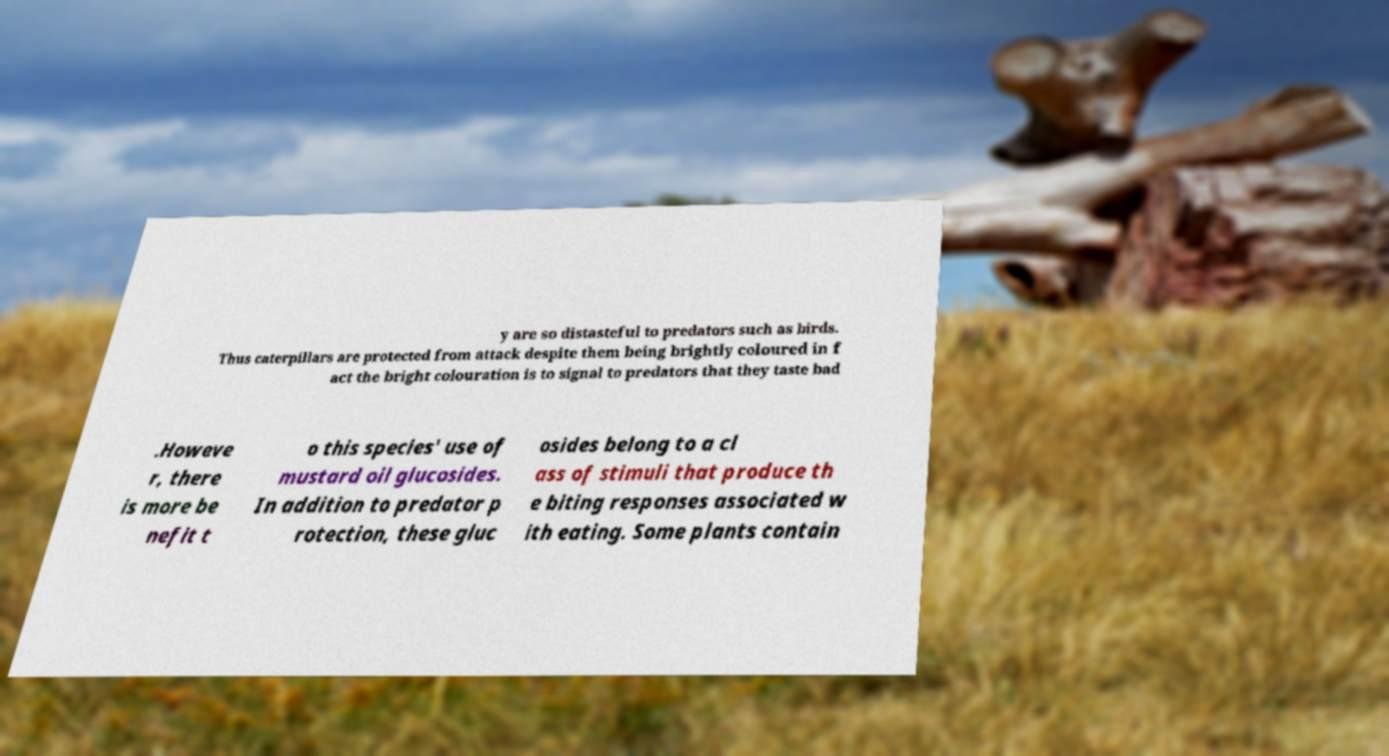What messages or text are displayed in this image? I need them in a readable, typed format. y are so distasteful to predators such as birds. Thus caterpillars are protected from attack despite them being brightly coloured in f act the bright colouration is to signal to predators that they taste bad .Howeve r, there is more be nefit t o this species' use of mustard oil glucosides. In addition to predator p rotection, these gluc osides belong to a cl ass of stimuli that produce th e biting responses associated w ith eating. Some plants contain 